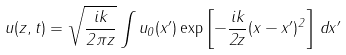<formula> <loc_0><loc_0><loc_500><loc_500>u ( z , t ) = \sqrt { \frac { i k } { 2 \pi z } } \int u _ { 0 } ( x ^ { \prime } ) \exp \left [ - \frac { i k } { 2 z } ( x - x ^ { \prime } ) ^ { 2 } \right ] \, d x ^ { \prime }</formula> 